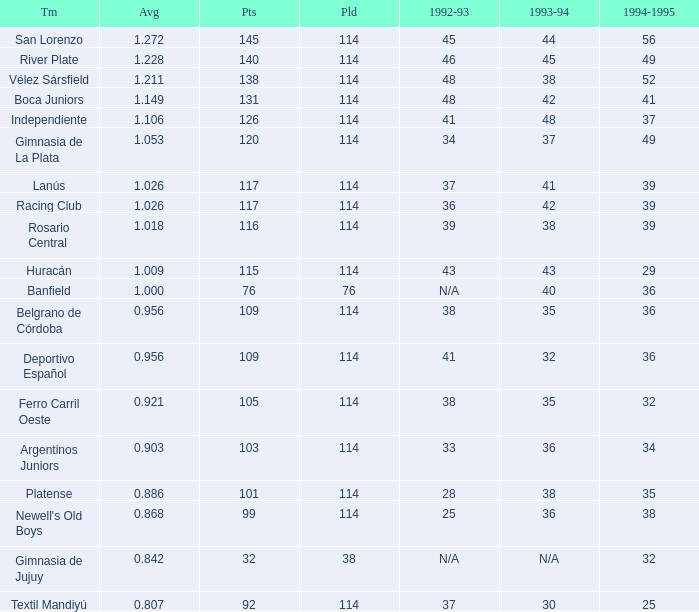Name the most played 114.0. 